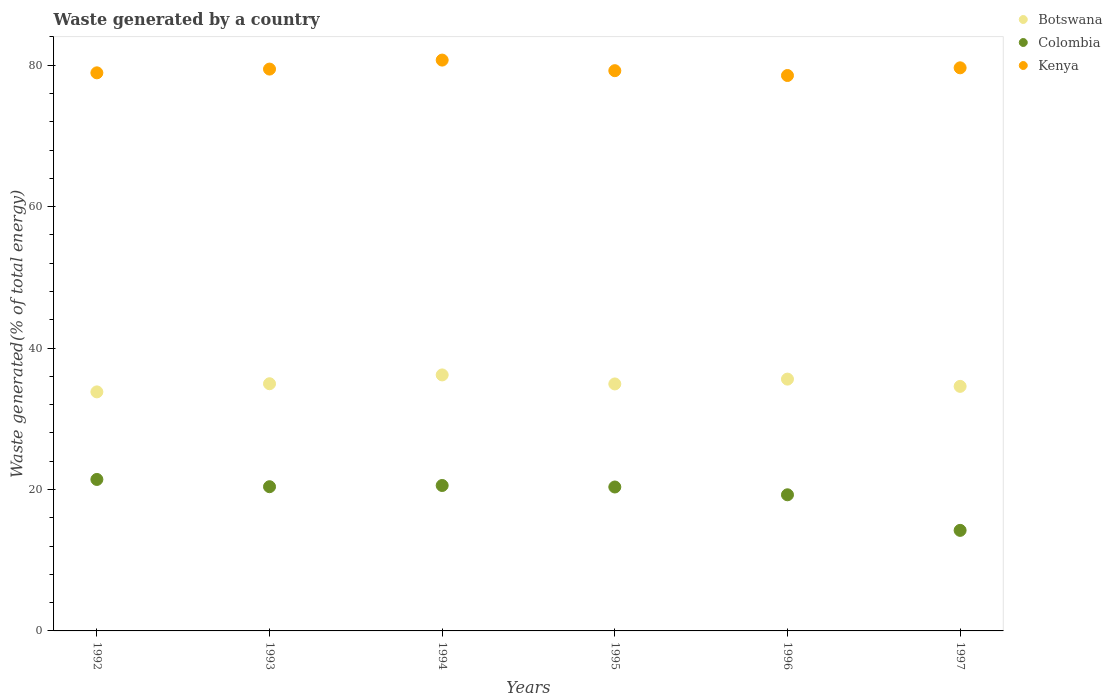How many different coloured dotlines are there?
Make the answer very short. 3. What is the total waste generated in Botswana in 1996?
Your response must be concise. 35.61. Across all years, what is the maximum total waste generated in Kenya?
Your answer should be compact. 80.73. Across all years, what is the minimum total waste generated in Botswana?
Provide a short and direct response. 33.8. What is the total total waste generated in Botswana in the graph?
Keep it short and to the point. 210.08. What is the difference between the total waste generated in Colombia in 1992 and that in 1995?
Keep it short and to the point. 1.07. What is the difference between the total waste generated in Colombia in 1994 and the total waste generated in Botswana in 1997?
Your answer should be compact. -14.02. What is the average total waste generated in Colombia per year?
Provide a succinct answer. 19.37. In the year 1995, what is the difference between the total waste generated in Colombia and total waste generated in Botswana?
Make the answer very short. -14.57. What is the ratio of the total waste generated in Colombia in 1993 to that in 1996?
Your response must be concise. 1.06. What is the difference between the highest and the second highest total waste generated in Colombia?
Ensure brevity in your answer.  0.86. What is the difference between the highest and the lowest total waste generated in Botswana?
Keep it short and to the point. 2.4. Is the sum of the total waste generated in Colombia in 1992 and 1995 greater than the maximum total waste generated in Botswana across all years?
Your answer should be very brief. Yes. Does the total waste generated in Botswana monotonically increase over the years?
Offer a terse response. No. Is the total waste generated in Botswana strictly greater than the total waste generated in Kenya over the years?
Ensure brevity in your answer.  No. How many dotlines are there?
Offer a terse response. 3. Does the graph contain any zero values?
Offer a terse response. No. Does the graph contain grids?
Give a very brief answer. No. Where does the legend appear in the graph?
Give a very brief answer. Top right. How many legend labels are there?
Your answer should be compact. 3. How are the legend labels stacked?
Your answer should be very brief. Vertical. What is the title of the graph?
Ensure brevity in your answer.  Waste generated by a country. What is the label or title of the Y-axis?
Your answer should be very brief. Waste generated(% of total energy). What is the Waste generated(% of total energy) of Botswana in 1992?
Provide a short and direct response. 33.8. What is the Waste generated(% of total energy) of Colombia in 1992?
Your response must be concise. 21.42. What is the Waste generated(% of total energy) of Kenya in 1992?
Give a very brief answer. 78.92. What is the Waste generated(% of total energy) in Botswana in 1993?
Keep it short and to the point. 34.96. What is the Waste generated(% of total energy) of Colombia in 1993?
Your response must be concise. 20.4. What is the Waste generated(% of total energy) of Kenya in 1993?
Provide a succinct answer. 79.45. What is the Waste generated(% of total energy) of Botswana in 1994?
Give a very brief answer. 36.2. What is the Waste generated(% of total energy) of Colombia in 1994?
Your answer should be very brief. 20.57. What is the Waste generated(% of total energy) of Kenya in 1994?
Give a very brief answer. 80.73. What is the Waste generated(% of total energy) in Botswana in 1995?
Offer a very short reply. 34.93. What is the Waste generated(% of total energy) of Colombia in 1995?
Offer a very short reply. 20.35. What is the Waste generated(% of total energy) in Kenya in 1995?
Offer a terse response. 79.23. What is the Waste generated(% of total energy) of Botswana in 1996?
Make the answer very short. 35.61. What is the Waste generated(% of total energy) of Colombia in 1996?
Ensure brevity in your answer.  19.25. What is the Waste generated(% of total energy) of Kenya in 1996?
Your answer should be very brief. 78.55. What is the Waste generated(% of total energy) in Botswana in 1997?
Provide a short and direct response. 34.58. What is the Waste generated(% of total energy) in Colombia in 1997?
Provide a short and direct response. 14.22. What is the Waste generated(% of total energy) in Kenya in 1997?
Offer a terse response. 79.63. Across all years, what is the maximum Waste generated(% of total energy) in Botswana?
Offer a very short reply. 36.2. Across all years, what is the maximum Waste generated(% of total energy) in Colombia?
Provide a short and direct response. 21.42. Across all years, what is the maximum Waste generated(% of total energy) of Kenya?
Provide a short and direct response. 80.73. Across all years, what is the minimum Waste generated(% of total energy) in Botswana?
Offer a terse response. 33.8. Across all years, what is the minimum Waste generated(% of total energy) of Colombia?
Your answer should be very brief. 14.22. Across all years, what is the minimum Waste generated(% of total energy) in Kenya?
Your answer should be compact. 78.55. What is the total Waste generated(% of total energy) of Botswana in the graph?
Give a very brief answer. 210.08. What is the total Waste generated(% of total energy) of Colombia in the graph?
Your response must be concise. 116.21. What is the total Waste generated(% of total energy) of Kenya in the graph?
Provide a succinct answer. 476.51. What is the difference between the Waste generated(% of total energy) of Botswana in 1992 and that in 1993?
Provide a short and direct response. -1.15. What is the difference between the Waste generated(% of total energy) of Colombia in 1992 and that in 1993?
Your answer should be compact. 1.03. What is the difference between the Waste generated(% of total energy) in Kenya in 1992 and that in 1993?
Provide a succinct answer. -0.53. What is the difference between the Waste generated(% of total energy) in Botswana in 1992 and that in 1994?
Provide a short and direct response. -2.4. What is the difference between the Waste generated(% of total energy) of Colombia in 1992 and that in 1994?
Keep it short and to the point. 0.86. What is the difference between the Waste generated(% of total energy) of Kenya in 1992 and that in 1994?
Keep it short and to the point. -1.8. What is the difference between the Waste generated(% of total energy) of Botswana in 1992 and that in 1995?
Give a very brief answer. -1.12. What is the difference between the Waste generated(% of total energy) in Colombia in 1992 and that in 1995?
Your answer should be very brief. 1.07. What is the difference between the Waste generated(% of total energy) of Kenya in 1992 and that in 1995?
Give a very brief answer. -0.3. What is the difference between the Waste generated(% of total energy) in Botswana in 1992 and that in 1996?
Your answer should be very brief. -1.81. What is the difference between the Waste generated(% of total energy) of Colombia in 1992 and that in 1996?
Offer a terse response. 2.17. What is the difference between the Waste generated(% of total energy) of Kenya in 1992 and that in 1996?
Your answer should be very brief. 0.38. What is the difference between the Waste generated(% of total energy) of Botswana in 1992 and that in 1997?
Provide a succinct answer. -0.78. What is the difference between the Waste generated(% of total energy) of Colombia in 1992 and that in 1997?
Make the answer very short. 7.2. What is the difference between the Waste generated(% of total energy) in Kenya in 1992 and that in 1997?
Keep it short and to the point. -0.71. What is the difference between the Waste generated(% of total energy) in Botswana in 1993 and that in 1994?
Your answer should be compact. -1.25. What is the difference between the Waste generated(% of total energy) of Colombia in 1993 and that in 1994?
Your answer should be compact. -0.17. What is the difference between the Waste generated(% of total energy) of Kenya in 1993 and that in 1994?
Offer a terse response. -1.27. What is the difference between the Waste generated(% of total energy) of Botswana in 1993 and that in 1995?
Your answer should be very brief. 0.03. What is the difference between the Waste generated(% of total energy) of Colombia in 1993 and that in 1995?
Offer a terse response. 0.04. What is the difference between the Waste generated(% of total energy) in Kenya in 1993 and that in 1995?
Your answer should be compact. 0.23. What is the difference between the Waste generated(% of total energy) in Botswana in 1993 and that in 1996?
Make the answer very short. -0.65. What is the difference between the Waste generated(% of total energy) in Colombia in 1993 and that in 1996?
Ensure brevity in your answer.  1.14. What is the difference between the Waste generated(% of total energy) in Kenya in 1993 and that in 1996?
Keep it short and to the point. 0.91. What is the difference between the Waste generated(% of total energy) in Botswana in 1993 and that in 1997?
Offer a terse response. 0.37. What is the difference between the Waste generated(% of total energy) in Colombia in 1993 and that in 1997?
Provide a succinct answer. 6.18. What is the difference between the Waste generated(% of total energy) of Kenya in 1993 and that in 1997?
Make the answer very short. -0.18. What is the difference between the Waste generated(% of total energy) in Botswana in 1994 and that in 1995?
Provide a short and direct response. 1.28. What is the difference between the Waste generated(% of total energy) in Colombia in 1994 and that in 1995?
Provide a short and direct response. 0.21. What is the difference between the Waste generated(% of total energy) of Kenya in 1994 and that in 1995?
Offer a very short reply. 1.5. What is the difference between the Waste generated(% of total energy) in Botswana in 1994 and that in 1996?
Ensure brevity in your answer.  0.59. What is the difference between the Waste generated(% of total energy) in Colombia in 1994 and that in 1996?
Ensure brevity in your answer.  1.31. What is the difference between the Waste generated(% of total energy) of Kenya in 1994 and that in 1996?
Offer a very short reply. 2.18. What is the difference between the Waste generated(% of total energy) of Botswana in 1994 and that in 1997?
Provide a short and direct response. 1.62. What is the difference between the Waste generated(% of total energy) in Colombia in 1994 and that in 1997?
Your answer should be very brief. 6.35. What is the difference between the Waste generated(% of total energy) of Kenya in 1994 and that in 1997?
Give a very brief answer. 1.09. What is the difference between the Waste generated(% of total energy) of Botswana in 1995 and that in 1996?
Ensure brevity in your answer.  -0.68. What is the difference between the Waste generated(% of total energy) of Colombia in 1995 and that in 1996?
Your answer should be very brief. 1.1. What is the difference between the Waste generated(% of total energy) of Kenya in 1995 and that in 1996?
Make the answer very short. 0.68. What is the difference between the Waste generated(% of total energy) in Botswana in 1995 and that in 1997?
Your answer should be compact. 0.34. What is the difference between the Waste generated(% of total energy) of Colombia in 1995 and that in 1997?
Provide a succinct answer. 6.13. What is the difference between the Waste generated(% of total energy) of Kenya in 1995 and that in 1997?
Make the answer very short. -0.41. What is the difference between the Waste generated(% of total energy) of Botswana in 1996 and that in 1997?
Ensure brevity in your answer.  1.02. What is the difference between the Waste generated(% of total energy) in Colombia in 1996 and that in 1997?
Give a very brief answer. 5.03. What is the difference between the Waste generated(% of total energy) of Kenya in 1996 and that in 1997?
Give a very brief answer. -1.09. What is the difference between the Waste generated(% of total energy) of Botswana in 1992 and the Waste generated(% of total energy) of Colombia in 1993?
Make the answer very short. 13.41. What is the difference between the Waste generated(% of total energy) in Botswana in 1992 and the Waste generated(% of total energy) in Kenya in 1993?
Offer a terse response. -45.65. What is the difference between the Waste generated(% of total energy) in Colombia in 1992 and the Waste generated(% of total energy) in Kenya in 1993?
Provide a short and direct response. -58.03. What is the difference between the Waste generated(% of total energy) in Botswana in 1992 and the Waste generated(% of total energy) in Colombia in 1994?
Keep it short and to the point. 13.24. What is the difference between the Waste generated(% of total energy) in Botswana in 1992 and the Waste generated(% of total energy) in Kenya in 1994?
Offer a terse response. -46.92. What is the difference between the Waste generated(% of total energy) in Colombia in 1992 and the Waste generated(% of total energy) in Kenya in 1994?
Offer a very short reply. -59.3. What is the difference between the Waste generated(% of total energy) of Botswana in 1992 and the Waste generated(% of total energy) of Colombia in 1995?
Your response must be concise. 13.45. What is the difference between the Waste generated(% of total energy) of Botswana in 1992 and the Waste generated(% of total energy) of Kenya in 1995?
Ensure brevity in your answer.  -45.42. What is the difference between the Waste generated(% of total energy) of Colombia in 1992 and the Waste generated(% of total energy) of Kenya in 1995?
Provide a succinct answer. -57.81. What is the difference between the Waste generated(% of total energy) of Botswana in 1992 and the Waste generated(% of total energy) of Colombia in 1996?
Provide a short and direct response. 14.55. What is the difference between the Waste generated(% of total energy) in Botswana in 1992 and the Waste generated(% of total energy) in Kenya in 1996?
Provide a short and direct response. -44.74. What is the difference between the Waste generated(% of total energy) in Colombia in 1992 and the Waste generated(% of total energy) in Kenya in 1996?
Ensure brevity in your answer.  -57.12. What is the difference between the Waste generated(% of total energy) in Botswana in 1992 and the Waste generated(% of total energy) in Colombia in 1997?
Keep it short and to the point. 19.58. What is the difference between the Waste generated(% of total energy) in Botswana in 1992 and the Waste generated(% of total energy) in Kenya in 1997?
Your answer should be very brief. -45.83. What is the difference between the Waste generated(% of total energy) of Colombia in 1992 and the Waste generated(% of total energy) of Kenya in 1997?
Keep it short and to the point. -58.21. What is the difference between the Waste generated(% of total energy) in Botswana in 1993 and the Waste generated(% of total energy) in Colombia in 1994?
Make the answer very short. 14.39. What is the difference between the Waste generated(% of total energy) of Botswana in 1993 and the Waste generated(% of total energy) of Kenya in 1994?
Give a very brief answer. -45.77. What is the difference between the Waste generated(% of total energy) in Colombia in 1993 and the Waste generated(% of total energy) in Kenya in 1994?
Provide a succinct answer. -60.33. What is the difference between the Waste generated(% of total energy) in Botswana in 1993 and the Waste generated(% of total energy) in Colombia in 1995?
Keep it short and to the point. 14.6. What is the difference between the Waste generated(% of total energy) in Botswana in 1993 and the Waste generated(% of total energy) in Kenya in 1995?
Offer a very short reply. -44.27. What is the difference between the Waste generated(% of total energy) of Colombia in 1993 and the Waste generated(% of total energy) of Kenya in 1995?
Make the answer very short. -58.83. What is the difference between the Waste generated(% of total energy) in Botswana in 1993 and the Waste generated(% of total energy) in Colombia in 1996?
Ensure brevity in your answer.  15.71. What is the difference between the Waste generated(% of total energy) of Botswana in 1993 and the Waste generated(% of total energy) of Kenya in 1996?
Your response must be concise. -43.59. What is the difference between the Waste generated(% of total energy) of Colombia in 1993 and the Waste generated(% of total energy) of Kenya in 1996?
Your answer should be very brief. -58.15. What is the difference between the Waste generated(% of total energy) of Botswana in 1993 and the Waste generated(% of total energy) of Colombia in 1997?
Keep it short and to the point. 20.74. What is the difference between the Waste generated(% of total energy) of Botswana in 1993 and the Waste generated(% of total energy) of Kenya in 1997?
Ensure brevity in your answer.  -44.68. What is the difference between the Waste generated(% of total energy) of Colombia in 1993 and the Waste generated(% of total energy) of Kenya in 1997?
Your answer should be very brief. -59.24. What is the difference between the Waste generated(% of total energy) of Botswana in 1994 and the Waste generated(% of total energy) of Colombia in 1995?
Offer a terse response. 15.85. What is the difference between the Waste generated(% of total energy) of Botswana in 1994 and the Waste generated(% of total energy) of Kenya in 1995?
Your response must be concise. -43.02. What is the difference between the Waste generated(% of total energy) of Colombia in 1994 and the Waste generated(% of total energy) of Kenya in 1995?
Make the answer very short. -58.66. What is the difference between the Waste generated(% of total energy) of Botswana in 1994 and the Waste generated(% of total energy) of Colombia in 1996?
Offer a terse response. 16.95. What is the difference between the Waste generated(% of total energy) of Botswana in 1994 and the Waste generated(% of total energy) of Kenya in 1996?
Your answer should be compact. -42.34. What is the difference between the Waste generated(% of total energy) of Colombia in 1994 and the Waste generated(% of total energy) of Kenya in 1996?
Offer a terse response. -57.98. What is the difference between the Waste generated(% of total energy) in Botswana in 1994 and the Waste generated(% of total energy) in Colombia in 1997?
Your answer should be very brief. 21.98. What is the difference between the Waste generated(% of total energy) of Botswana in 1994 and the Waste generated(% of total energy) of Kenya in 1997?
Make the answer very short. -43.43. What is the difference between the Waste generated(% of total energy) of Colombia in 1994 and the Waste generated(% of total energy) of Kenya in 1997?
Your response must be concise. -59.07. What is the difference between the Waste generated(% of total energy) of Botswana in 1995 and the Waste generated(% of total energy) of Colombia in 1996?
Your answer should be compact. 15.68. What is the difference between the Waste generated(% of total energy) in Botswana in 1995 and the Waste generated(% of total energy) in Kenya in 1996?
Ensure brevity in your answer.  -43.62. What is the difference between the Waste generated(% of total energy) of Colombia in 1995 and the Waste generated(% of total energy) of Kenya in 1996?
Provide a short and direct response. -58.19. What is the difference between the Waste generated(% of total energy) of Botswana in 1995 and the Waste generated(% of total energy) of Colombia in 1997?
Your answer should be compact. 20.71. What is the difference between the Waste generated(% of total energy) of Botswana in 1995 and the Waste generated(% of total energy) of Kenya in 1997?
Offer a very short reply. -44.71. What is the difference between the Waste generated(% of total energy) in Colombia in 1995 and the Waste generated(% of total energy) in Kenya in 1997?
Ensure brevity in your answer.  -59.28. What is the difference between the Waste generated(% of total energy) in Botswana in 1996 and the Waste generated(% of total energy) in Colombia in 1997?
Provide a short and direct response. 21.39. What is the difference between the Waste generated(% of total energy) of Botswana in 1996 and the Waste generated(% of total energy) of Kenya in 1997?
Ensure brevity in your answer.  -44.02. What is the difference between the Waste generated(% of total energy) of Colombia in 1996 and the Waste generated(% of total energy) of Kenya in 1997?
Provide a short and direct response. -60.38. What is the average Waste generated(% of total energy) in Botswana per year?
Ensure brevity in your answer.  35.01. What is the average Waste generated(% of total energy) in Colombia per year?
Give a very brief answer. 19.37. What is the average Waste generated(% of total energy) of Kenya per year?
Your response must be concise. 79.42. In the year 1992, what is the difference between the Waste generated(% of total energy) in Botswana and Waste generated(% of total energy) in Colombia?
Your response must be concise. 12.38. In the year 1992, what is the difference between the Waste generated(% of total energy) in Botswana and Waste generated(% of total energy) in Kenya?
Ensure brevity in your answer.  -45.12. In the year 1992, what is the difference between the Waste generated(% of total energy) in Colombia and Waste generated(% of total energy) in Kenya?
Provide a succinct answer. -57.5. In the year 1993, what is the difference between the Waste generated(% of total energy) in Botswana and Waste generated(% of total energy) in Colombia?
Your answer should be compact. 14.56. In the year 1993, what is the difference between the Waste generated(% of total energy) in Botswana and Waste generated(% of total energy) in Kenya?
Give a very brief answer. -44.5. In the year 1993, what is the difference between the Waste generated(% of total energy) of Colombia and Waste generated(% of total energy) of Kenya?
Offer a terse response. -59.06. In the year 1994, what is the difference between the Waste generated(% of total energy) of Botswana and Waste generated(% of total energy) of Colombia?
Your response must be concise. 15.64. In the year 1994, what is the difference between the Waste generated(% of total energy) of Botswana and Waste generated(% of total energy) of Kenya?
Keep it short and to the point. -44.52. In the year 1994, what is the difference between the Waste generated(% of total energy) of Colombia and Waste generated(% of total energy) of Kenya?
Keep it short and to the point. -60.16. In the year 1995, what is the difference between the Waste generated(% of total energy) in Botswana and Waste generated(% of total energy) in Colombia?
Make the answer very short. 14.57. In the year 1995, what is the difference between the Waste generated(% of total energy) in Botswana and Waste generated(% of total energy) in Kenya?
Your response must be concise. -44.3. In the year 1995, what is the difference between the Waste generated(% of total energy) of Colombia and Waste generated(% of total energy) of Kenya?
Your answer should be very brief. -58.87. In the year 1996, what is the difference between the Waste generated(% of total energy) in Botswana and Waste generated(% of total energy) in Colombia?
Your answer should be compact. 16.36. In the year 1996, what is the difference between the Waste generated(% of total energy) in Botswana and Waste generated(% of total energy) in Kenya?
Your response must be concise. -42.94. In the year 1996, what is the difference between the Waste generated(% of total energy) of Colombia and Waste generated(% of total energy) of Kenya?
Give a very brief answer. -59.3. In the year 1997, what is the difference between the Waste generated(% of total energy) of Botswana and Waste generated(% of total energy) of Colombia?
Your response must be concise. 20.37. In the year 1997, what is the difference between the Waste generated(% of total energy) of Botswana and Waste generated(% of total energy) of Kenya?
Keep it short and to the point. -45.05. In the year 1997, what is the difference between the Waste generated(% of total energy) in Colombia and Waste generated(% of total energy) in Kenya?
Offer a terse response. -65.41. What is the ratio of the Waste generated(% of total energy) of Colombia in 1992 to that in 1993?
Offer a very short reply. 1.05. What is the ratio of the Waste generated(% of total energy) in Kenya in 1992 to that in 1993?
Offer a very short reply. 0.99. What is the ratio of the Waste generated(% of total energy) of Botswana in 1992 to that in 1994?
Keep it short and to the point. 0.93. What is the ratio of the Waste generated(% of total energy) in Colombia in 1992 to that in 1994?
Provide a short and direct response. 1.04. What is the ratio of the Waste generated(% of total energy) of Kenya in 1992 to that in 1994?
Provide a succinct answer. 0.98. What is the ratio of the Waste generated(% of total energy) in Botswana in 1992 to that in 1995?
Provide a succinct answer. 0.97. What is the ratio of the Waste generated(% of total energy) in Colombia in 1992 to that in 1995?
Provide a succinct answer. 1.05. What is the ratio of the Waste generated(% of total energy) in Kenya in 1992 to that in 1995?
Provide a succinct answer. 1. What is the ratio of the Waste generated(% of total energy) in Botswana in 1992 to that in 1996?
Make the answer very short. 0.95. What is the ratio of the Waste generated(% of total energy) of Colombia in 1992 to that in 1996?
Your answer should be compact. 1.11. What is the ratio of the Waste generated(% of total energy) in Botswana in 1992 to that in 1997?
Your response must be concise. 0.98. What is the ratio of the Waste generated(% of total energy) of Colombia in 1992 to that in 1997?
Offer a terse response. 1.51. What is the ratio of the Waste generated(% of total energy) in Botswana in 1993 to that in 1994?
Your answer should be very brief. 0.97. What is the ratio of the Waste generated(% of total energy) in Colombia in 1993 to that in 1994?
Provide a succinct answer. 0.99. What is the ratio of the Waste generated(% of total energy) of Kenya in 1993 to that in 1994?
Provide a succinct answer. 0.98. What is the ratio of the Waste generated(% of total energy) in Colombia in 1993 to that in 1995?
Give a very brief answer. 1. What is the ratio of the Waste generated(% of total energy) in Botswana in 1993 to that in 1996?
Your answer should be very brief. 0.98. What is the ratio of the Waste generated(% of total energy) of Colombia in 1993 to that in 1996?
Keep it short and to the point. 1.06. What is the ratio of the Waste generated(% of total energy) in Kenya in 1993 to that in 1996?
Give a very brief answer. 1.01. What is the ratio of the Waste generated(% of total energy) in Botswana in 1993 to that in 1997?
Offer a very short reply. 1.01. What is the ratio of the Waste generated(% of total energy) of Colombia in 1993 to that in 1997?
Offer a terse response. 1.43. What is the ratio of the Waste generated(% of total energy) in Kenya in 1993 to that in 1997?
Make the answer very short. 1. What is the ratio of the Waste generated(% of total energy) in Botswana in 1994 to that in 1995?
Give a very brief answer. 1.04. What is the ratio of the Waste generated(% of total energy) in Colombia in 1994 to that in 1995?
Ensure brevity in your answer.  1.01. What is the ratio of the Waste generated(% of total energy) of Kenya in 1994 to that in 1995?
Your answer should be compact. 1.02. What is the ratio of the Waste generated(% of total energy) in Botswana in 1994 to that in 1996?
Make the answer very short. 1.02. What is the ratio of the Waste generated(% of total energy) of Colombia in 1994 to that in 1996?
Your answer should be compact. 1.07. What is the ratio of the Waste generated(% of total energy) of Kenya in 1994 to that in 1996?
Offer a terse response. 1.03. What is the ratio of the Waste generated(% of total energy) in Botswana in 1994 to that in 1997?
Your answer should be very brief. 1.05. What is the ratio of the Waste generated(% of total energy) in Colombia in 1994 to that in 1997?
Your response must be concise. 1.45. What is the ratio of the Waste generated(% of total energy) of Kenya in 1994 to that in 1997?
Make the answer very short. 1.01. What is the ratio of the Waste generated(% of total energy) of Botswana in 1995 to that in 1996?
Give a very brief answer. 0.98. What is the ratio of the Waste generated(% of total energy) in Colombia in 1995 to that in 1996?
Keep it short and to the point. 1.06. What is the ratio of the Waste generated(% of total energy) in Kenya in 1995 to that in 1996?
Give a very brief answer. 1.01. What is the ratio of the Waste generated(% of total energy) in Botswana in 1995 to that in 1997?
Provide a short and direct response. 1.01. What is the ratio of the Waste generated(% of total energy) in Colombia in 1995 to that in 1997?
Make the answer very short. 1.43. What is the ratio of the Waste generated(% of total energy) in Kenya in 1995 to that in 1997?
Your response must be concise. 0.99. What is the ratio of the Waste generated(% of total energy) of Botswana in 1996 to that in 1997?
Offer a very short reply. 1.03. What is the ratio of the Waste generated(% of total energy) in Colombia in 1996 to that in 1997?
Your answer should be very brief. 1.35. What is the ratio of the Waste generated(% of total energy) of Kenya in 1996 to that in 1997?
Make the answer very short. 0.99. What is the difference between the highest and the second highest Waste generated(% of total energy) in Botswana?
Make the answer very short. 0.59. What is the difference between the highest and the second highest Waste generated(% of total energy) of Colombia?
Give a very brief answer. 0.86. What is the difference between the highest and the second highest Waste generated(% of total energy) of Kenya?
Provide a succinct answer. 1.09. What is the difference between the highest and the lowest Waste generated(% of total energy) of Botswana?
Offer a very short reply. 2.4. What is the difference between the highest and the lowest Waste generated(% of total energy) in Colombia?
Provide a short and direct response. 7.2. What is the difference between the highest and the lowest Waste generated(% of total energy) in Kenya?
Make the answer very short. 2.18. 